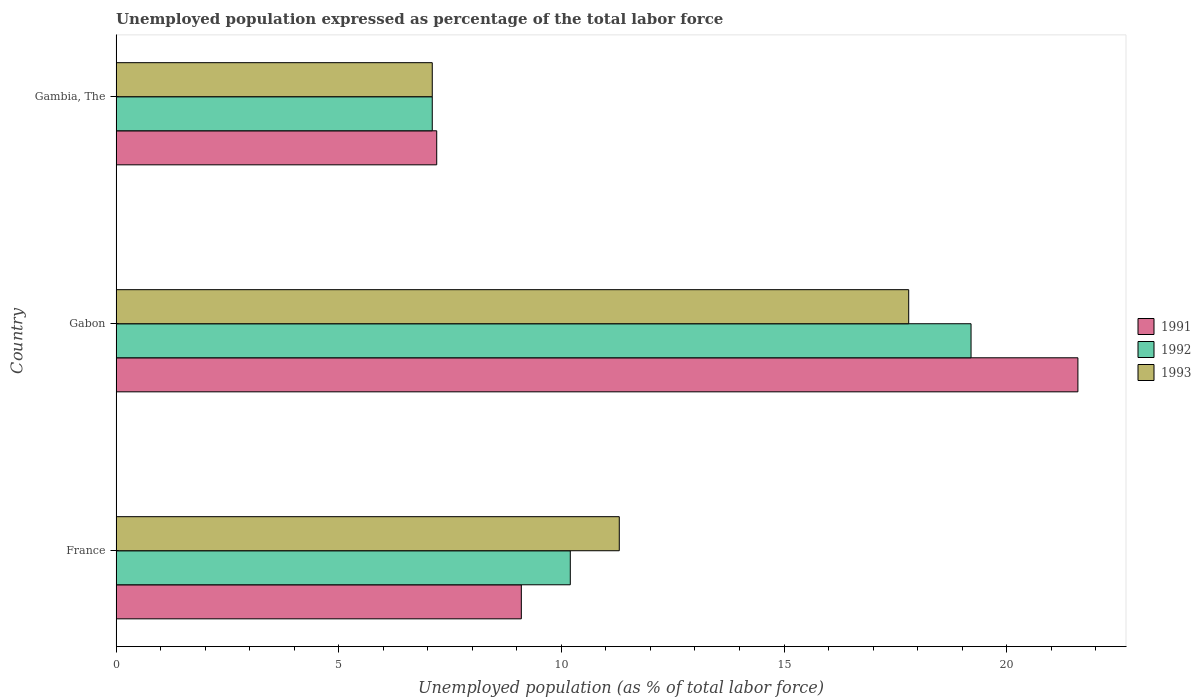How many groups of bars are there?
Make the answer very short. 3. What is the label of the 1st group of bars from the top?
Your answer should be very brief. Gambia, The. What is the unemployment in in 1992 in Gambia, The?
Offer a terse response. 7.1. Across all countries, what is the maximum unemployment in in 1991?
Your response must be concise. 21.6. Across all countries, what is the minimum unemployment in in 1993?
Offer a terse response. 7.1. In which country was the unemployment in in 1992 maximum?
Provide a succinct answer. Gabon. In which country was the unemployment in in 1992 minimum?
Provide a short and direct response. Gambia, The. What is the total unemployment in in 1991 in the graph?
Provide a succinct answer. 37.9. What is the difference between the unemployment in in 1991 in Gabon and that in Gambia, The?
Keep it short and to the point. 14.4. What is the difference between the unemployment in in 1992 in Gambia, The and the unemployment in in 1991 in Gabon?
Offer a terse response. -14.5. What is the average unemployment in in 1993 per country?
Ensure brevity in your answer.  12.07. What is the difference between the unemployment in in 1993 and unemployment in in 1991 in France?
Ensure brevity in your answer.  2.2. What is the ratio of the unemployment in in 1991 in France to that in Gabon?
Give a very brief answer. 0.42. Is the difference between the unemployment in in 1993 in Gabon and Gambia, The greater than the difference between the unemployment in in 1991 in Gabon and Gambia, The?
Your answer should be very brief. No. What is the difference between the highest and the second highest unemployment in in 1993?
Your response must be concise. 6.5. What is the difference between the highest and the lowest unemployment in in 1993?
Provide a short and direct response. 10.7. Are all the bars in the graph horizontal?
Provide a succinct answer. Yes. How many countries are there in the graph?
Give a very brief answer. 3. What is the difference between two consecutive major ticks on the X-axis?
Your answer should be very brief. 5. Where does the legend appear in the graph?
Offer a very short reply. Center right. How are the legend labels stacked?
Ensure brevity in your answer.  Vertical. What is the title of the graph?
Offer a terse response. Unemployed population expressed as percentage of the total labor force. Does "1973" appear as one of the legend labels in the graph?
Give a very brief answer. No. What is the label or title of the X-axis?
Your response must be concise. Unemployed population (as % of total labor force). What is the Unemployed population (as % of total labor force) of 1991 in France?
Give a very brief answer. 9.1. What is the Unemployed population (as % of total labor force) in 1992 in France?
Keep it short and to the point. 10.2. What is the Unemployed population (as % of total labor force) in 1993 in France?
Ensure brevity in your answer.  11.3. What is the Unemployed population (as % of total labor force) in 1991 in Gabon?
Make the answer very short. 21.6. What is the Unemployed population (as % of total labor force) of 1992 in Gabon?
Your answer should be compact. 19.2. What is the Unemployed population (as % of total labor force) of 1993 in Gabon?
Keep it short and to the point. 17.8. What is the Unemployed population (as % of total labor force) in 1991 in Gambia, The?
Offer a terse response. 7.2. What is the Unemployed population (as % of total labor force) of 1992 in Gambia, The?
Offer a very short reply. 7.1. What is the Unemployed population (as % of total labor force) in 1993 in Gambia, The?
Make the answer very short. 7.1. Across all countries, what is the maximum Unemployed population (as % of total labor force) of 1991?
Offer a very short reply. 21.6. Across all countries, what is the maximum Unemployed population (as % of total labor force) of 1992?
Provide a succinct answer. 19.2. Across all countries, what is the maximum Unemployed population (as % of total labor force) of 1993?
Your answer should be very brief. 17.8. Across all countries, what is the minimum Unemployed population (as % of total labor force) in 1991?
Provide a succinct answer. 7.2. Across all countries, what is the minimum Unemployed population (as % of total labor force) of 1992?
Offer a very short reply. 7.1. Across all countries, what is the minimum Unemployed population (as % of total labor force) in 1993?
Your response must be concise. 7.1. What is the total Unemployed population (as % of total labor force) in 1991 in the graph?
Offer a terse response. 37.9. What is the total Unemployed population (as % of total labor force) of 1992 in the graph?
Provide a short and direct response. 36.5. What is the total Unemployed population (as % of total labor force) of 1993 in the graph?
Your answer should be compact. 36.2. What is the difference between the Unemployed population (as % of total labor force) of 1993 in France and that in Gabon?
Give a very brief answer. -6.5. What is the difference between the Unemployed population (as % of total labor force) of 1991 in France and that in Gambia, The?
Your answer should be very brief. 1.9. What is the difference between the Unemployed population (as % of total labor force) in 1992 in France and that in Gambia, The?
Your answer should be compact. 3.1. What is the difference between the Unemployed population (as % of total labor force) of 1991 in France and the Unemployed population (as % of total labor force) of 1993 in Gabon?
Offer a very short reply. -8.7. What is the difference between the Unemployed population (as % of total labor force) of 1992 in France and the Unemployed population (as % of total labor force) of 1993 in Gabon?
Provide a short and direct response. -7.6. What is the average Unemployed population (as % of total labor force) in 1991 per country?
Provide a succinct answer. 12.63. What is the average Unemployed population (as % of total labor force) of 1992 per country?
Provide a short and direct response. 12.17. What is the average Unemployed population (as % of total labor force) of 1993 per country?
Make the answer very short. 12.07. What is the difference between the Unemployed population (as % of total labor force) in 1991 and Unemployed population (as % of total labor force) in 1992 in France?
Your answer should be compact. -1.1. What is the difference between the Unemployed population (as % of total labor force) of 1992 and Unemployed population (as % of total labor force) of 1993 in France?
Make the answer very short. -1.1. What is the difference between the Unemployed population (as % of total labor force) of 1991 and Unemployed population (as % of total labor force) of 1992 in Gabon?
Keep it short and to the point. 2.4. What is the difference between the Unemployed population (as % of total labor force) in 1991 and Unemployed population (as % of total labor force) in 1993 in Gabon?
Give a very brief answer. 3.8. What is the difference between the Unemployed population (as % of total labor force) of 1991 and Unemployed population (as % of total labor force) of 1992 in Gambia, The?
Make the answer very short. 0.1. What is the difference between the Unemployed population (as % of total labor force) in 1991 and Unemployed population (as % of total labor force) in 1993 in Gambia, The?
Ensure brevity in your answer.  0.1. What is the ratio of the Unemployed population (as % of total labor force) in 1991 in France to that in Gabon?
Ensure brevity in your answer.  0.42. What is the ratio of the Unemployed population (as % of total labor force) of 1992 in France to that in Gabon?
Keep it short and to the point. 0.53. What is the ratio of the Unemployed population (as % of total labor force) of 1993 in France to that in Gabon?
Offer a terse response. 0.63. What is the ratio of the Unemployed population (as % of total labor force) in 1991 in France to that in Gambia, The?
Offer a terse response. 1.26. What is the ratio of the Unemployed population (as % of total labor force) of 1992 in France to that in Gambia, The?
Ensure brevity in your answer.  1.44. What is the ratio of the Unemployed population (as % of total labor force) of 1993 in France to that in Gambia, The?
Your response must be concise. 1.59. What is the ratio of the Unemployed population (as % of total labor force) in 1992 in Gabon to that in Gambia, The?
Provide a succinct answer. 2.7. What is the ratio of the Unemployed population (as % of total labor force) in 1993 in Gabon to that in Gambia, The?
Give a very brief answer. 2.51. What is the difference between the highest and the second highest Unemployed population (as % of total labor force) in 1991?
Your answer should be compact. 12.5. What is the difference between the highest and the second highest Unemployed population (as % of total labor force) in 1992?
Ensure brevity in your answer.  9. What is the difference between the highest and the lowest Unemployed population (as % of total labor force) of 1991?
Ensure brevity in your answer.  14.4. 